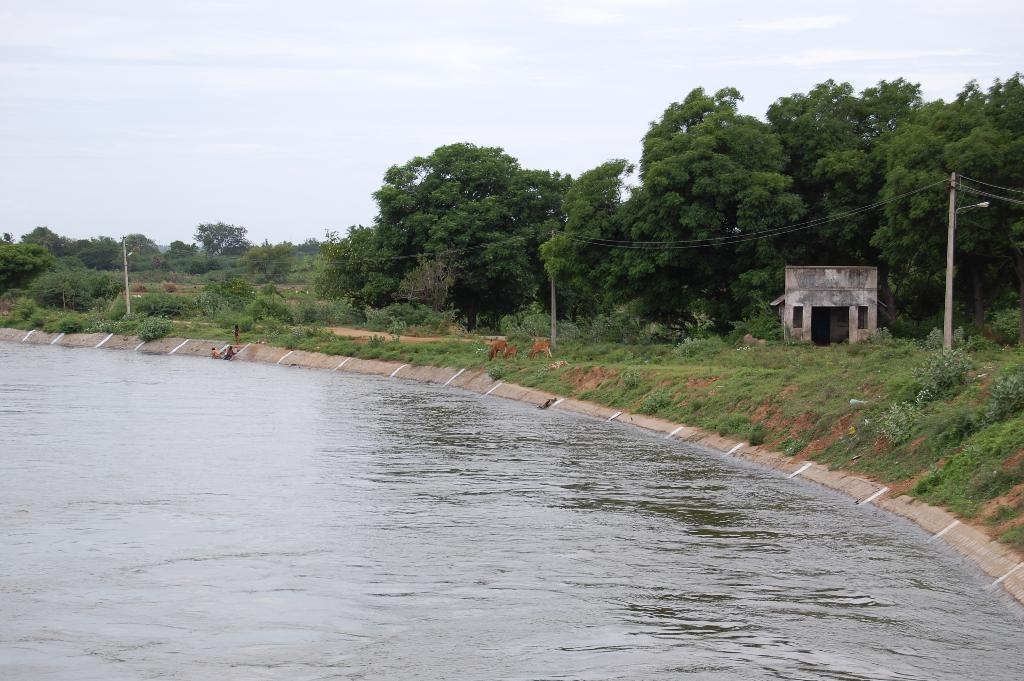What type of vegetation can be seen in the image? There are trees in the image. What else can be seen in the image besides trees? There is water visible in the image, as well as plants on the ground. What is the condition of the sky in the image? The sky is visible in the image and is cloudy. What structures are present in the image? There are poles with lights and a house in the image. Can you tell me how many dogs are drinking eggnog in the image? There are no dogs or eggnog present in the image. What type of feather can be seen on the house in the image? There is no feather present on the house in the image. 